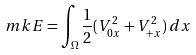<formula> <loc_0><loc_0><loc_500><loc_500>\ m k { E } = \int _ { \Omega } \frac { 1 } { 2 } ( V _ { 0 x } ^ { 2 } + V _ { + x } ^ { 2 } ) \, d x</formula> 